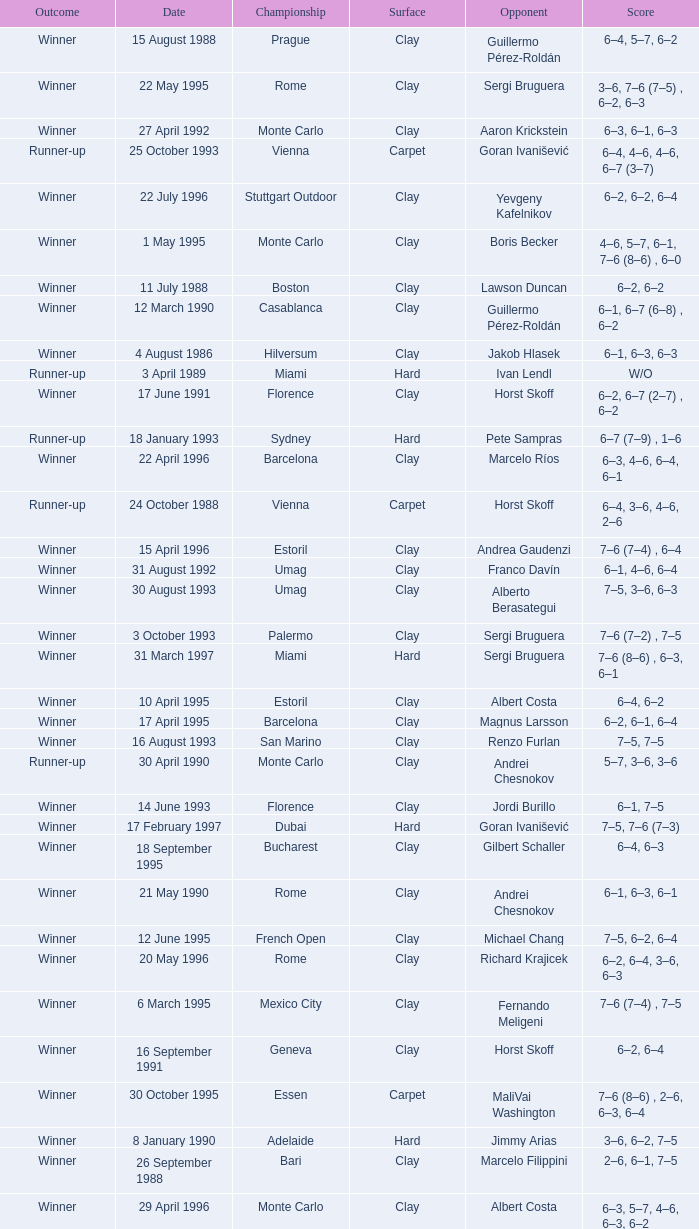What is the score when the outcome is winner against yevgeny kafelnikov? 6–2, 6–2, 6–4. 